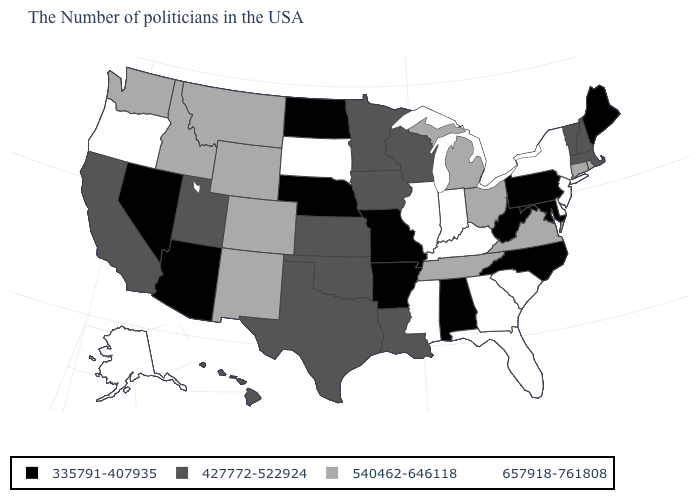Which states hav the highest value in the West?
Quick response, please. Oregon, Alaska. What is the value of Missouri?
Quick response, please. 335791-407935. Which states hav the highest value in the West?
Concise answer only. Oregon, Alaska. What is the value of North Carolina?
Write a very short answer. 335791-407935. Does Nebraska have the lowest value in the MidWest?
Quick response, please. Yes. What is the highest value in states that border Vermont?
Write a very short answer. 657918-761808. Name the states that have a value in the range 540462-646118?
Write a very short answer. Rhode Island, Connecticut, Virginia, Ohio, Michigan, Tennessee, Wyoming, Colorado, New Mexico, Montana, Idaho, Washington. Name the states that have a value in the range 540462-646118?
Concise answer only. Rhode Island, Connecticut, Virginia, Ohio, Michigan, Tennessee, Wyoming, Colorado, New Mexico, Montana, Idaho, Washington. What is the value of Alabama?
Short answer required. 335791-407935. Among the states that border Maryland , does Pennsylvania have the lowest value?
Give a very brief answer. Yes. What is the value of Colorado?
Be succinct. 540462-646118. What is the lowest value in the MidWest?
Concise answer only. 335791-407935. What is the highest value in states that border New Jersey?
Concise answer only. 657918-761808. Does Vermont have the lowest value in the Northeast?
Short answer required. No. What is the highest value in states that border Minnesota?
Concise answer only. 657918-761808. 